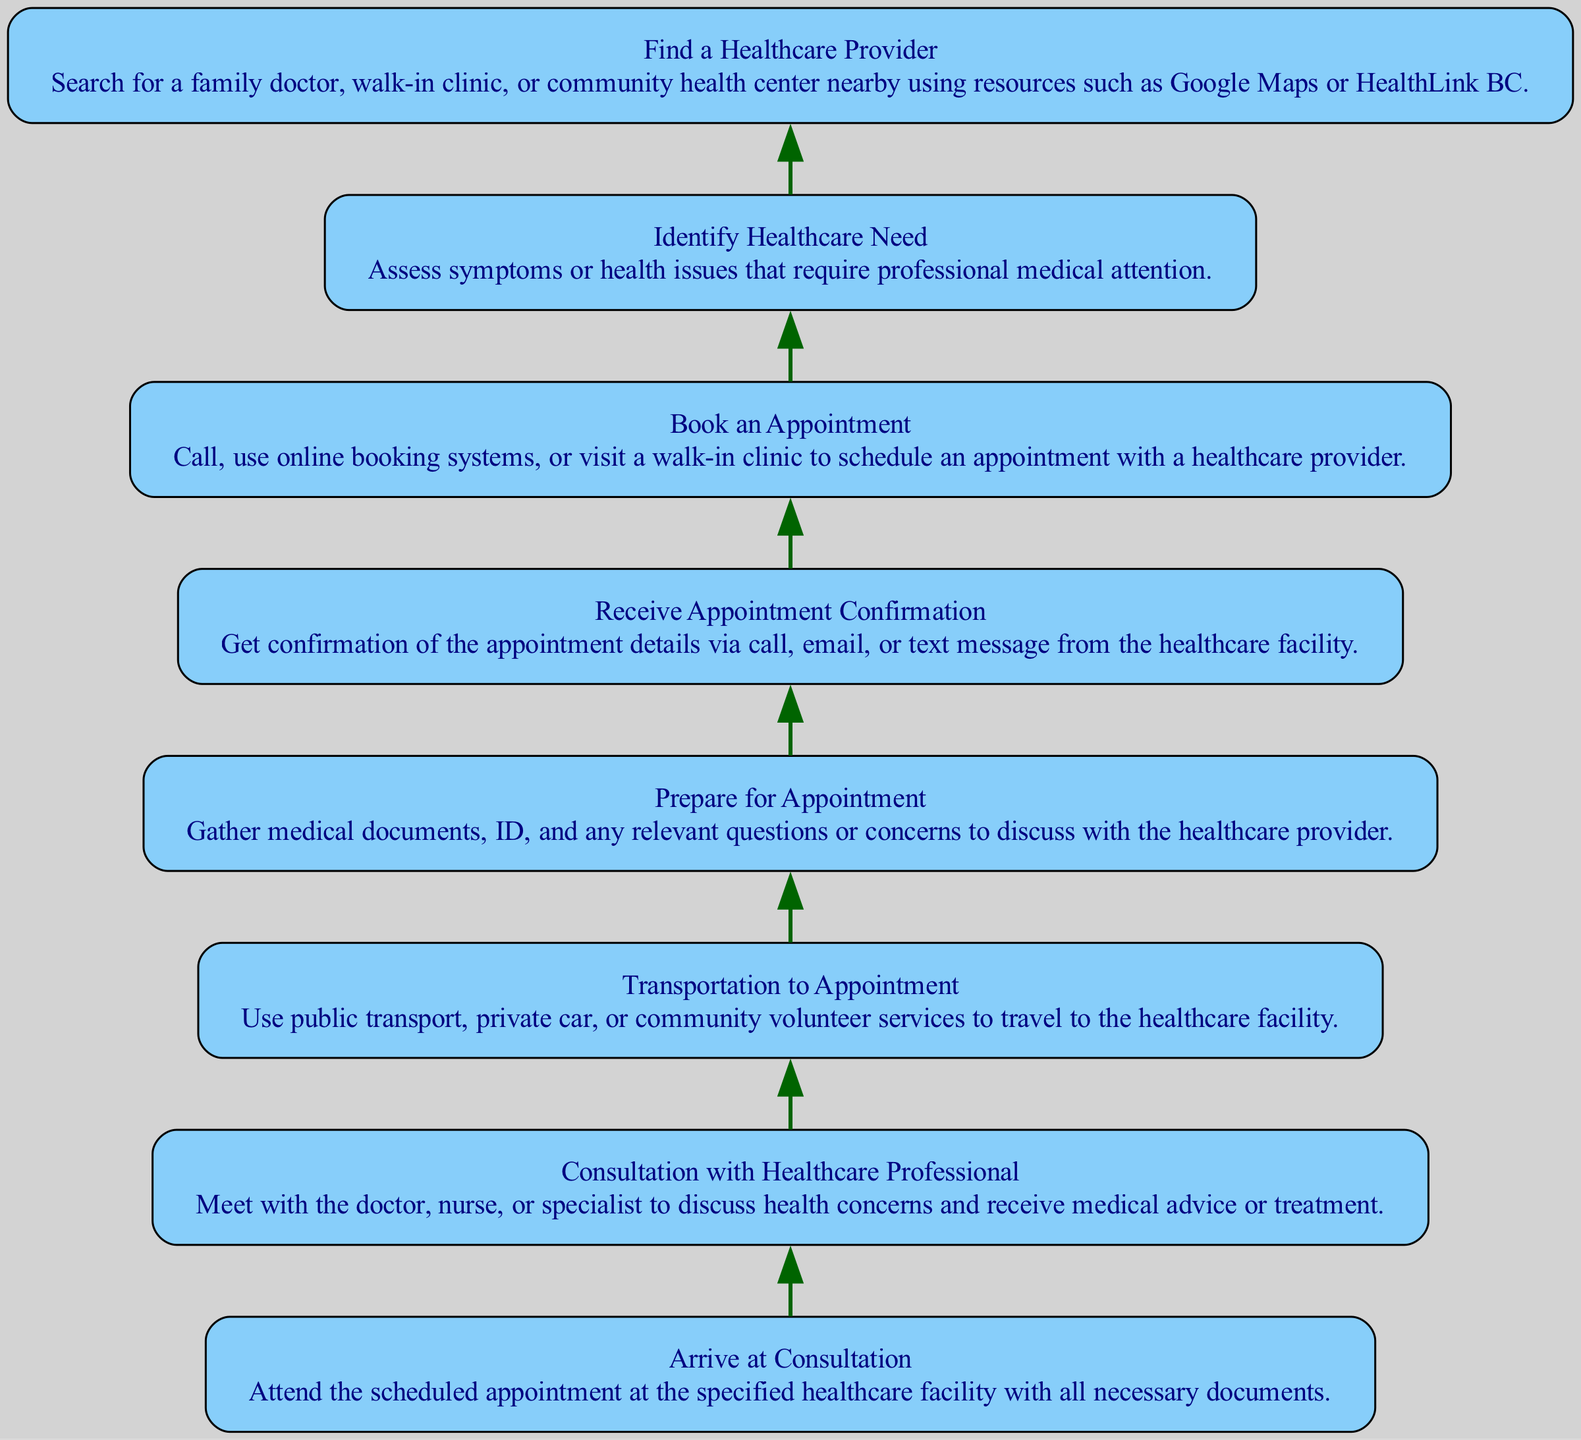What is the first step to navigate the Canadian healthcare system? The first step in the flowchart is "Identify Healthcare Need." This is the starting point where a person assesses their symptoms or health issues that require professional medical attention.
Answer: Identify Healthcare Need How many nodes are there in the diagram? The diagram contains a total of 8 nodes. Each step in the process from identifying healthcare needs to attending the consultation is represented by a separate node.
Answer: 8 What node comes after "Book an Appointment"? The node that comes after "Book an Appointment" is "Receive Appointment Confirmation." This indicates that after scheduling an appointment, the next step is to confirm the appointment details through various communication methods.
Answer: Receive Appointment Confirmation Which node directly leads to "Consultation with Healthcare Professional"? The node that directly leads to "Consultation with Healthcare Professional" is "Arrive at Consultation." This step involves attending the scheduled appointment at the healthcare facility, which allows for the consultation to occur.
Answer: Arrive at Consultation What mode of transportation can be used to reach appointments as per the diagram? The diagram mentions "public transport, private car, or community volunteer services" as modes of transportation that can be used to travel to appointments. These options provide flexibility depending on availability and preference.
Answer: public transport, private car, or community volunteer services What are the last two steps before attending the consultation? The last two steps before attending the consultation, in sequence, are "Prepare for Appointment" followed by "Arrive at Consultation." Preparing involves gathering necessary documents and questions, and arriving signifies attending the appointment.
Answer: Prepare for Appointment, Arrive at Consultation What does the "Find a Healthcare Provider" node entail? The "Find a Healthcare Provider" node involves searching for a family doctor, walk-in clinic, or community health center nearby. This can be done by utilizing resources like Google Maps or HealthLink BC to locate suitable healthcare providers.
Answer: Searching for healthcare providers What is the flow direction of this diagram? The flow direction of this diagram is from bottom to top, indicating the step-by-step process that one follows to navigate the Canadian healthcare system, starting from identifying needs up to attending the consultation.
Answer: Bottom to top 